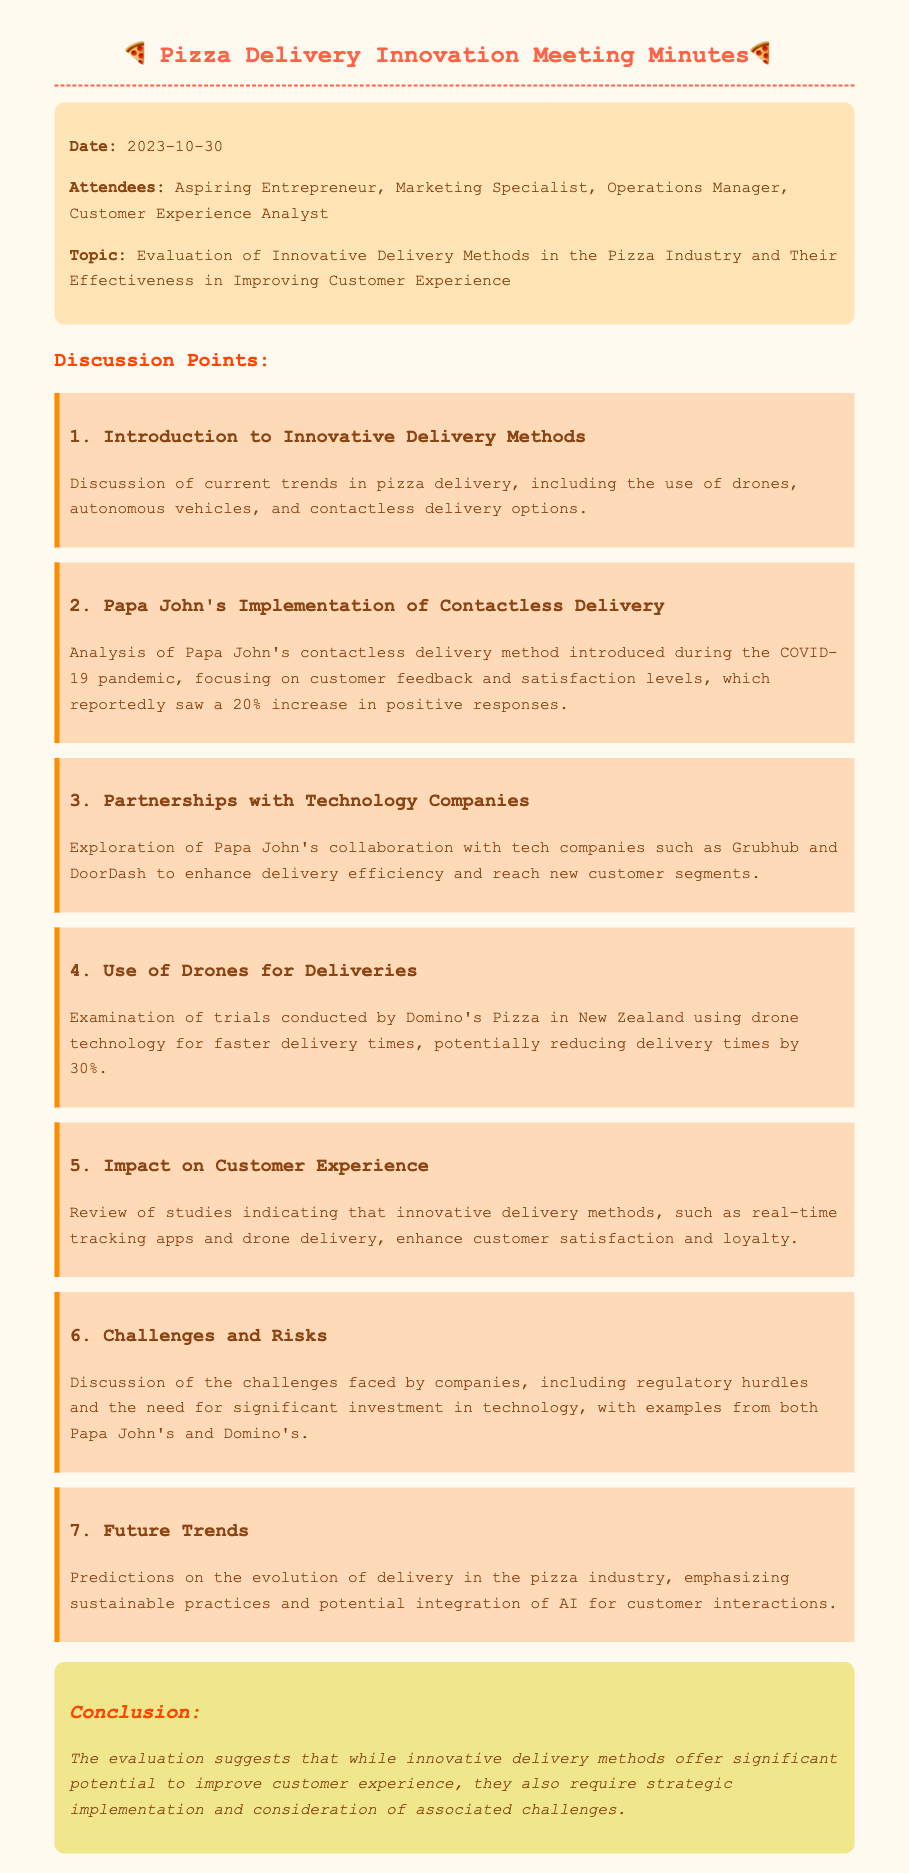What is the date of the meeting? The date of the meeting is explicitly stated in the document header.
Answer: 2023-10-30 Who are the attendees? The attendees listed in the document are the individuals present during the meeting.
Answer: Aspiring Entrepreneur, Marketing Specialist, Operations Manager, Customer Experience Analyst What delivery method did Papa John's implement during the COVID-19 pandemic? The document mentions the specific delivery method focused on by Papa John's during a critical time.
Answer: Contactless delivery What was the reported increase in positive customer feedback for Papa John's contactless delivery? The document includes a specific percentage indicating customer feedback improvement.
Answer: 20% What technology company did Papa John's collaborate with for enhanced delivery efficiency? The document lists partnerships with technology companies to boost delivery services.
Answer: Grubhub and DoorDash How much could Domino's potentially reduce delivery times by using drone technology? The document provides specific numerical information regarding delivery time reduction through drones.
Answer: 30% What are the discussed future trends in pizza delivery? The document outlines predictions related to the evolution of delivery strategies in the pizza industry.
Answer: Sustainable practices and potential integration of AI What challenge is mentioned regarding the implementation of innovative delivery methods? The document touches on difficulties faced by companies when adopting new delivery innovations.
Answer: Regulatory hurdles What is the overall conclusion stated in the document? The conclusion summarizes the findings discussed throughout the meeting regarding delivery innovations.
Answer: Significant potential to improve customer experience 